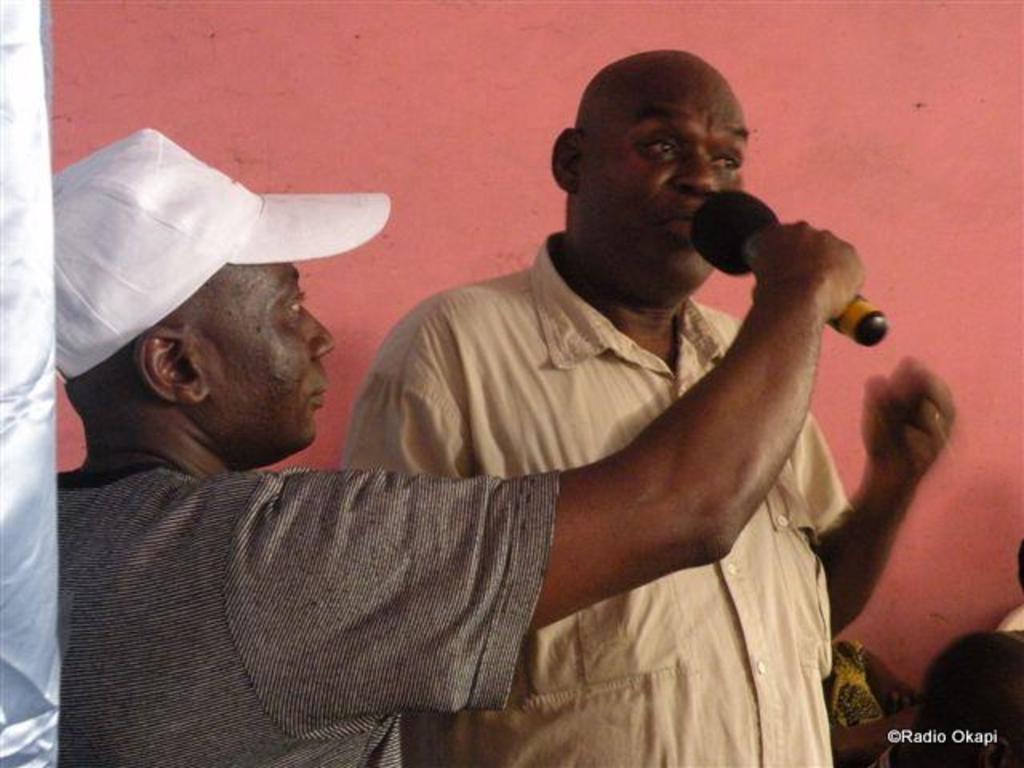How many people are present in the image? There are two men standing in the image. What is one of the men holding in his hand? One man is holding a microphone in his hand. What type of sock is the man wearing on his left foot? There is no information about socks or footwear in the image, so it cannot be determined what type of sock the man might be wearing. 